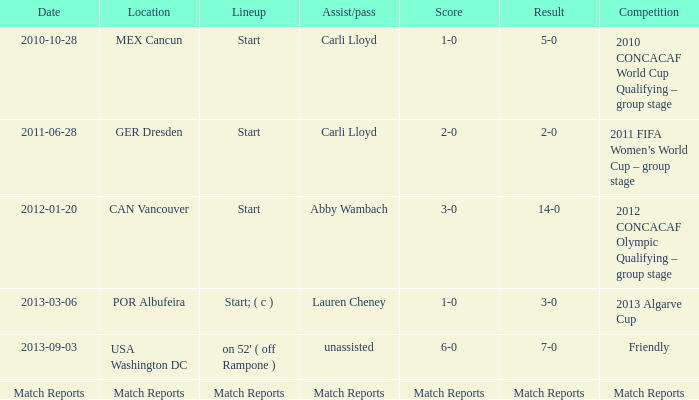Identify the roster featuring carli lloyd's assist/pass in the 2010 concacaf world cup qualifying - group stage competition? Start. 